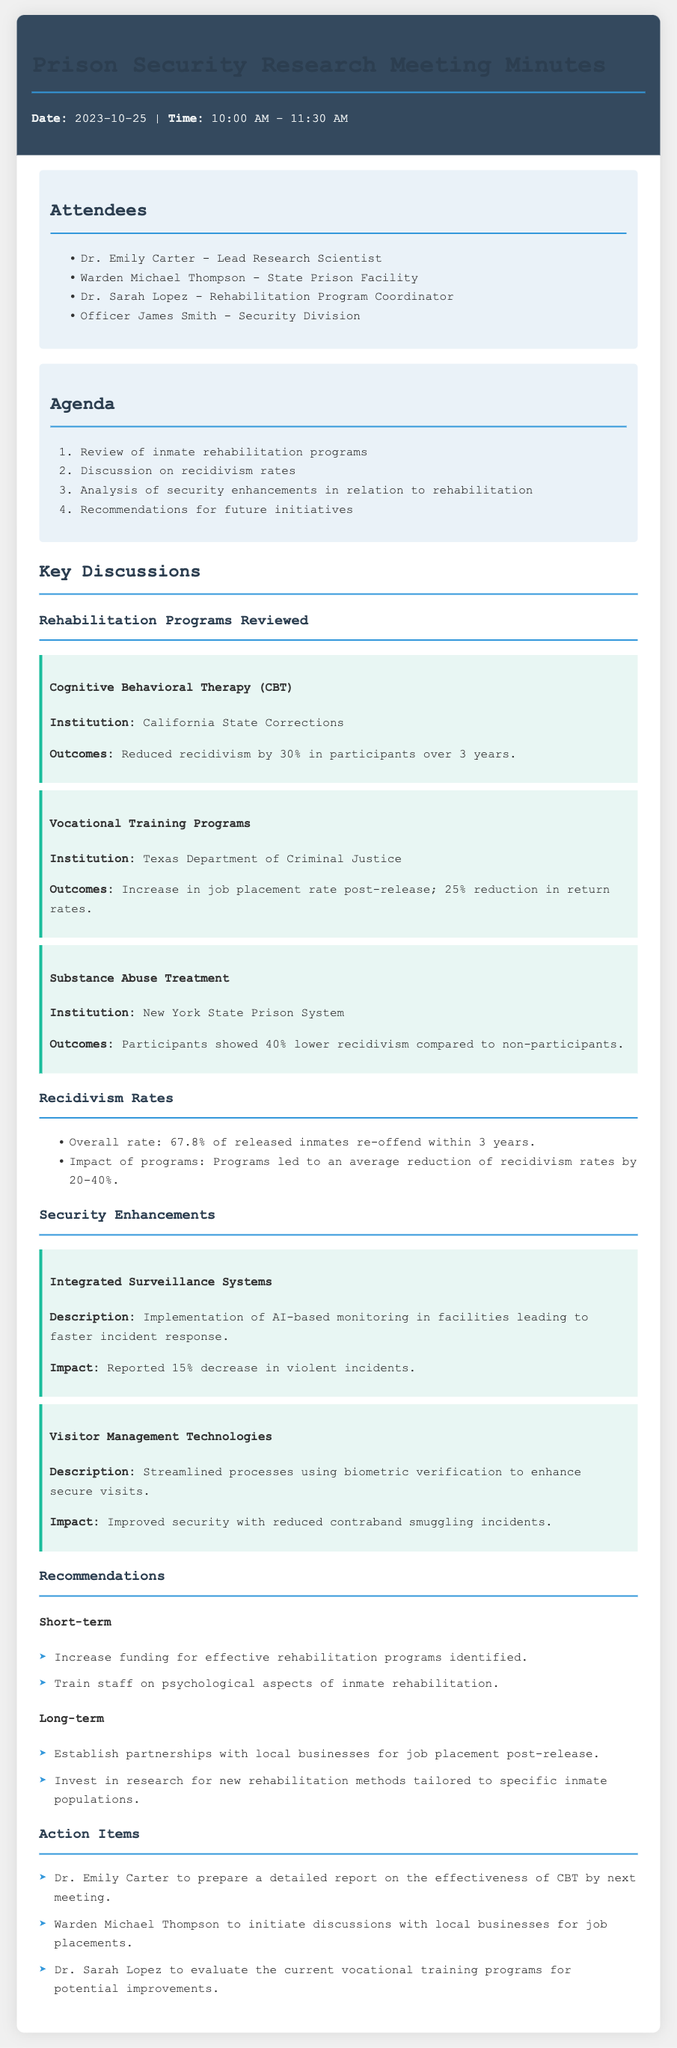What was the date of the meeting? The meeting was held on October 25, 2023.
Answer: October 25, 2023 Who is the Lead Research Scientist? The Lead Research Scientist is Dr. Emily Carter, mentioned in the attendees section.
Answer: Dr. Emily Carter What is the outcome of the Substance Abuse Treatment program? The outcome of the Substance Abuse Treatment program was a 40% lower recidivism rate compared to non-participants.
Answer: 40% lower What percentage of released inmates re-offend within three years? The document states that the overall rate of released inmates re-offending is 67.8%.
Answer: 67.8% What technology was implemented for better visitor management? The document mentions the use of biometric verification for visitor management technologies.
Answer: Biometric verification What are the action items for Dr. Sarah Lopez? Dr. Sarah Lopez's action item is to evaluate the current vocational training programs for potential improvements.
Answer: Evaluate vocational training programs What is the reported impact of Integrated Surveillance Systems? The Integrated Surveillance Systems resulted in a reported 15% decrease in violent incidents.
Answer: 15% decrease What is one of the recommendations for short-term initiatives? One short-term recommendation is to increase funding for effective rehabilitation programs identified.
Answer: Increase funding for rehabilitation programs What should Warden Michael Thompson initiate discussions about? Warden Michael Thompson should initiate discussions with local businesses for job placements.
Answer: Job placements with local businesses 